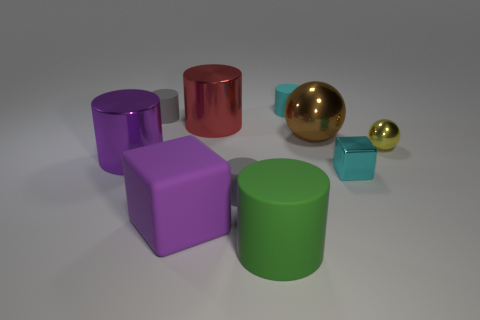Subtract 1 cylinders. How many cylinders are left? 5 Subtract all big red cylinders. How many cylinders are left? 5 Subtract all purple cylinders. How many cylinders are left? 5 Subtract all yellow cylinders. Subtract all red blocks. How many cylinders are left? 6 Subtract all cubes. How many objects are left? 8 Add 6 tiny cyan matte things. How many tiny cyan matte things exist? 7 Subtract 0 green balls. How many objects are left? 10 Subtract all purple matte objects. Subtract all yellow balls. How many objects are left? 8 Add 6 purple objects. How many purple objects are left? 8 